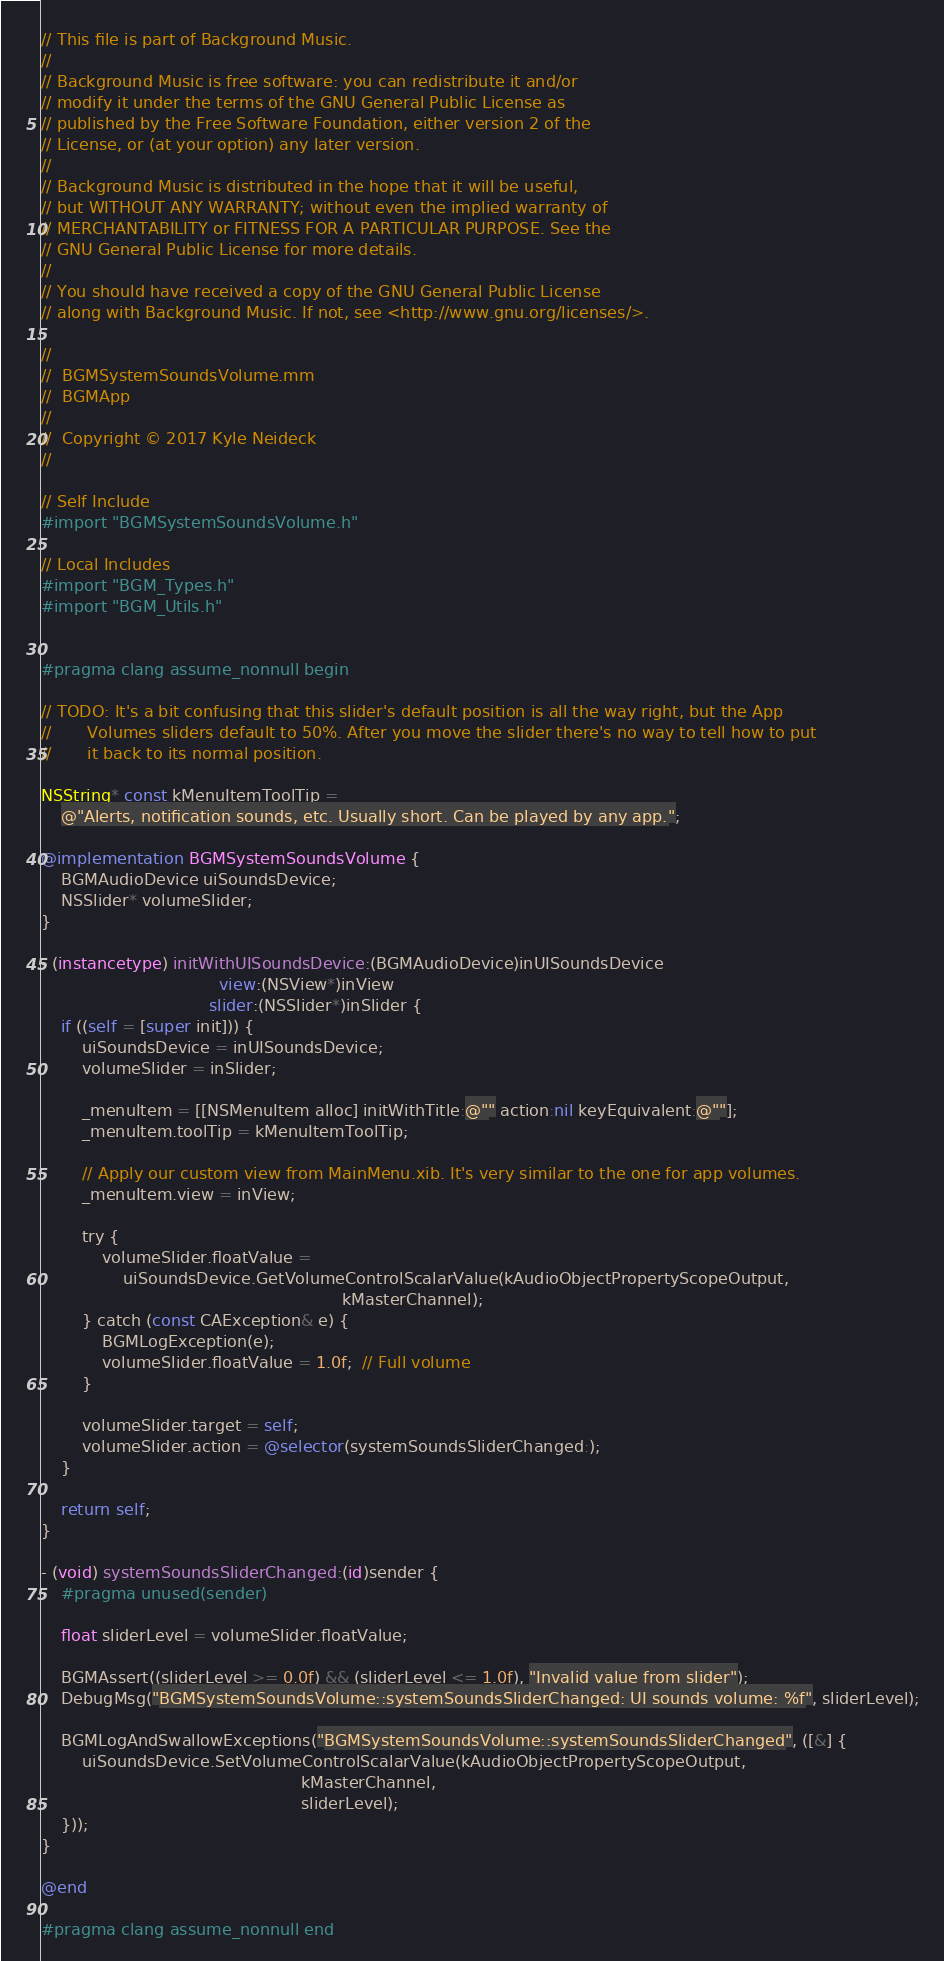<code> <loc_0><loc_0><loc_500><loc_500><_ObjectiveC_>// This file is part of Background Music.
//
// Background Music is free software: you can redistribute it and/or
// modify it under the terms of the GNU General Public License as
// published by the Free Software Foundation, either version 2 of the
// License, or (at your option) any later version.
//
// Background Music is distributed in the hope that it will be useful,
// but WITHOUT ANY WARRANTY; without even the implied warranty of
// MERCHANTABILITY or FITNESS FOR A PARTICULAR PURPOSE. See the
// GNU General Public License for more details.
//
// You should have received a copy of the GNU General Public License
// along with Background Music. If not, see <http://www.gnu.org/licenses/>.

//
//  BGMSystemSoundsVolume.mm
//  BGMApp
//
//  Copyright © 2017 Kyle Neideck
//

// Self Include
#import "BGMSystemSoundsVolume.h"

// Local Includes
#import "BGM_Types.h"
#import "BGM_Utils.h"


#pragma clang assume_nonnull begin

// TODO: It's a bit confusing that this slider's default position is all the way right, but the App
//       Volumes sliders default to 50%. After you move the slider there's no way to tell how to put
//       it back to its normal position.

NSString* const kMenuItemToolTip =
    @"Alerts, notification sounds, etc. Usually short. Can be played by any app.";

@implementation BGMSystemSoundsVolume {
    BGMAudioDevice uiSoundsDevice;
    NSSlider* volumeSlider;
}

- (instancetype) initWithUISoundsDevice:(BGMAudioDevice)inUISoundsDevice
                                   view:(NSView*)inView
                                 slider:(NSSlider*)inSlider {
    if ((self = [super init])) {
        uiSoundsDevice = inUISoundsDevice;
        volumeSlider = inSlider;

        _menuItem = [[NSMenuItem alloc] initWithTitle:@"" action:nil keyEquivalent:@""];
        _menuItem.toolTip = kMenuItemToolTip;

        // Apply our custom view from MainMenu.xib. It's very similar to the one for app volumes.
        _menuItem.view = inView;

        try {
            volumeSlider.floatValue =
                uiSoundsDevice.GetVolumeControlScalarValue(kAudioObjectPropertyScopeOutput,
                                                           kMasterChannel);
        } catch (const CAException& e) {
            BGMLogException(e);
            volumeSlider.floatValue = 1.0f;  // Full volume
        }

        volumeSlider.target = self;
        volumeSlider.action = @selector(systemSoundsSliderChanged:);
    }

    return self;
}

- (void) systemSoundsSliderChanged:(id)sender {
    #pragma unused(sender)

    float sliderLevel = volumeSlider.floatValue;

    BGMAssert((sliderLevel >= 0.0f) && (sliderLevel <= 1.0f), "Invalid value from slider");
    DebugMsg("BGMSystemSoundsVolume::systemSoundsSliderChanged: UI sounds volume: %f", sliderLevel);

    BGMLogAndSwallowExceptions("BGMSystemSoundsVolume::systemSoundsSliderChanged", ([&] {
        uiSoundsDevice.SetVolumeControlScalarValue(kAudioObjectPropertyScopeOutput,
                                                   kMasterChannel,
                                                   sliderLevel);
    }));
}

@end

#pragma clang assume_nonnull end

</code> 